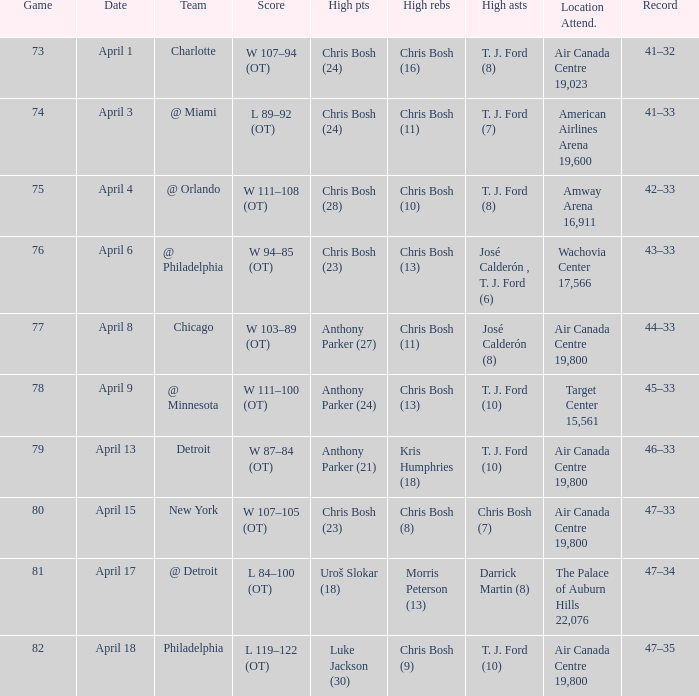What was the score of game 82? L 119–122 (OT). 